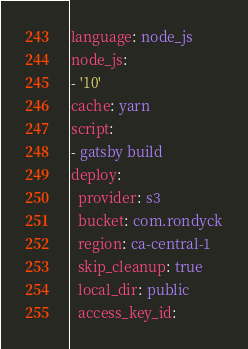<code> <loc_0><loc_0><loc_500><loc_500><_YAML_>language: node_js
node_js:
- '10'
cache: yarn
script:
- gatsby build
deploy:
  provider: s3
  bucket: com.rondyck
  region: ca-central-1
  skip_cleanup: true
  local_dir: public
  access_key_id:</code> 